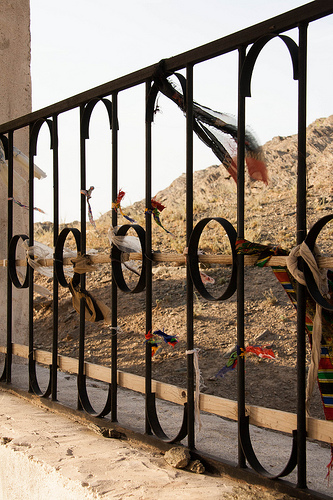<image>
Is there a sky behind the fence? Yes. From this viewpoint, the sky is positioned behind the fence, with the fence partially or fully occluding the sky. 